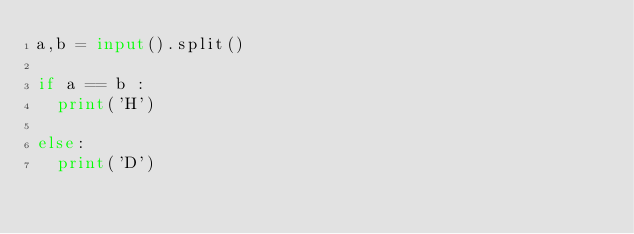Convert code to text. <code><loc_0><loc_0><loc_500><loc_500><_Python_>a,b = input().split()

if a == b :
  print('H')
 
else:
  print('D')</code> 